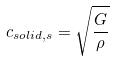Convert formula to latex. <formula><loc_0><loc_0><loc_500><loc_500>c _ { s o l i d , s } = \sqrt { \frac { G } { \rho } }</formula> 